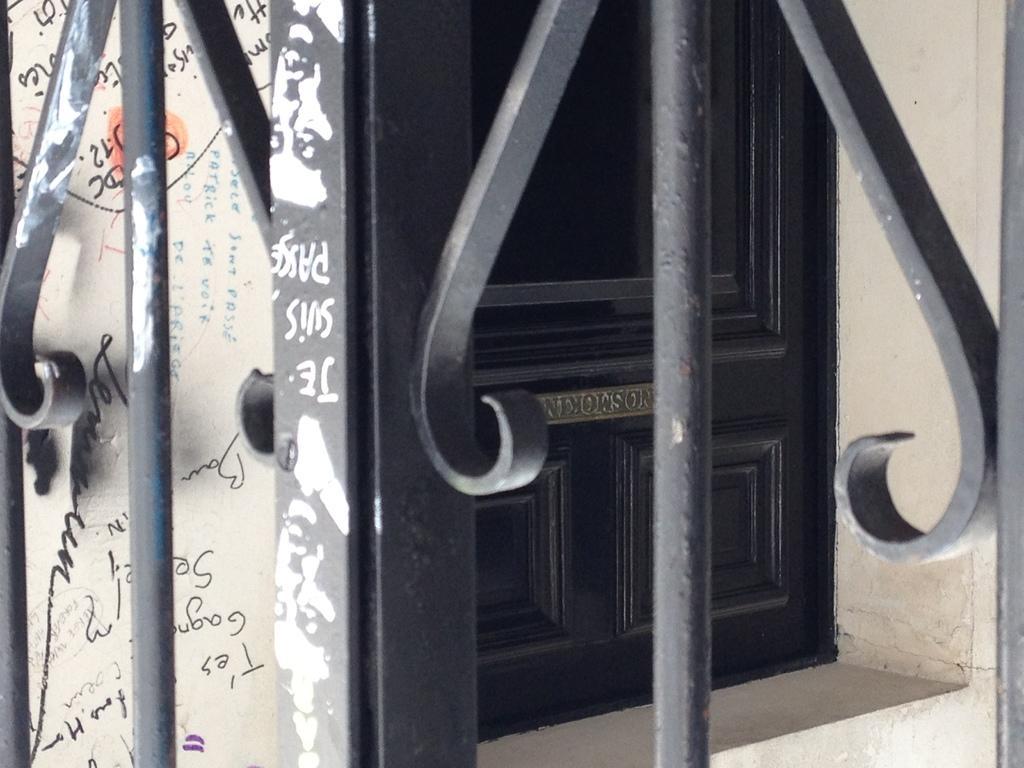Please provide a concise description of this image. In the image we can see a door, wall and fence. 